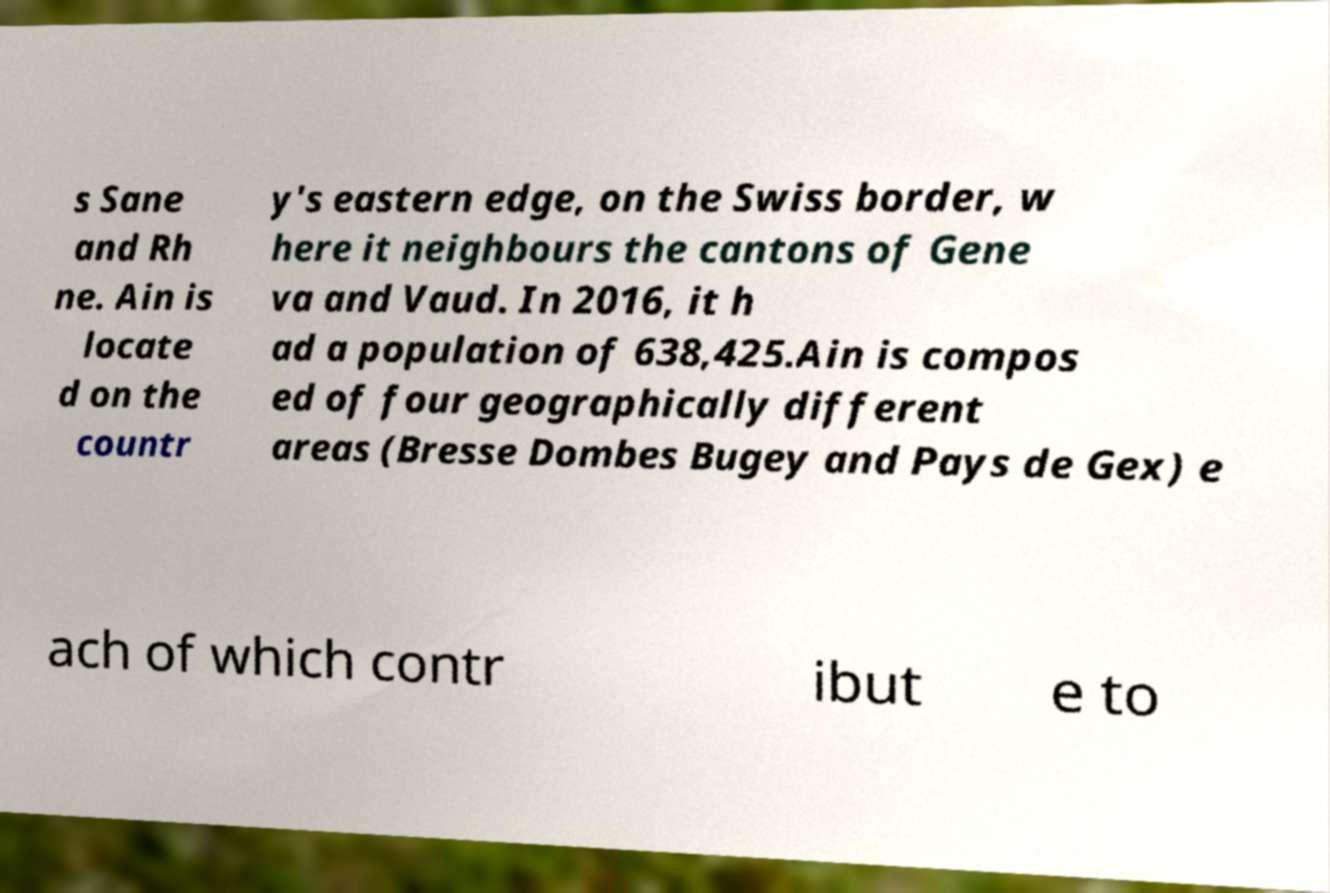For documentation purposes, I need the text within this image transcribed. Could you provide that? s Sane and Rh ne. Ain is locate d on the countr y's eastern edge, on the Swiss border, w here it neighbours the cantons of Gene va and Vaud. In 2016, it h ad a population of 638,425.Ain is compos ed of four geographically different areas (Bresse Dombes Bugey and Pays de Gex) e ach of which contr ibut e to 